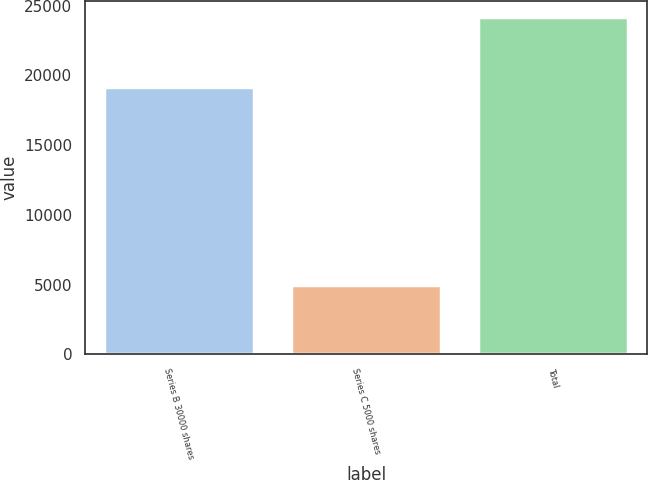Convert chart to OTSL. <chart><loc_0><loc_0><loc_500><loc_500><bar_chart><fcel>Series B 30000 shares<fcel>Series C 5000 shares<fcel>Total<nl><fcel>19160<fcel>5000<fcel>24160<nl></chart> 